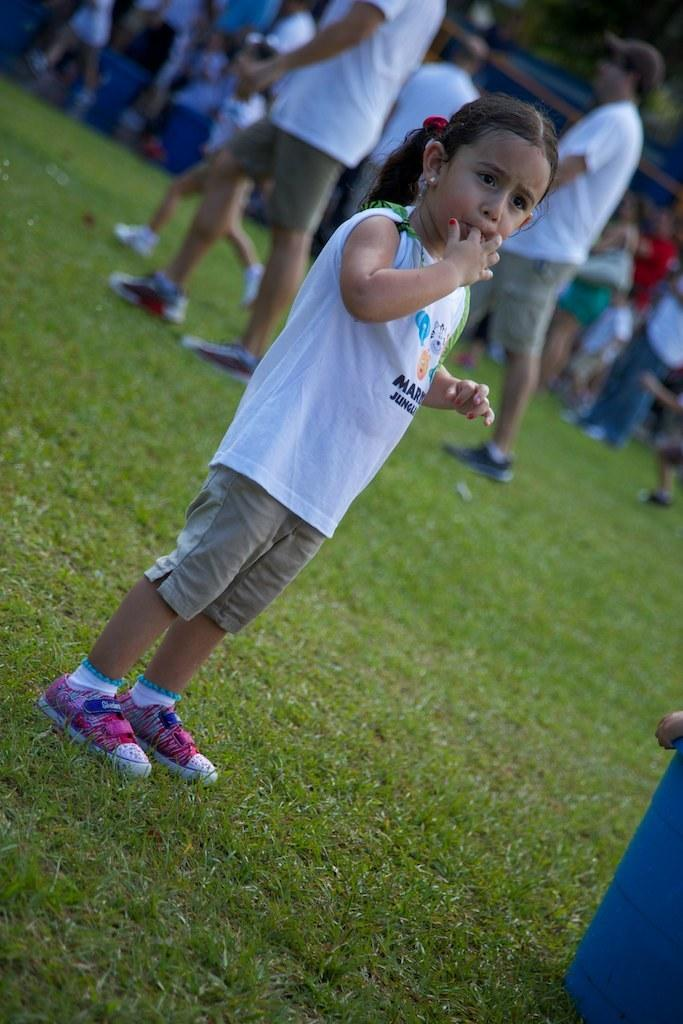What is the primary setting of the image? There are people standing on the ground in the image. Can you describe the girl in the image? The girl is standing in the image, wearing a white t-shirt, shorts, and shoes. What type of vegetation is visible in the image? There is grass visible in the image. What type of oil can be seen dripping from the girl's hair in the image? There is no oil visible in the image, nor is there any indication that the girl's hair is dripping with oil. 